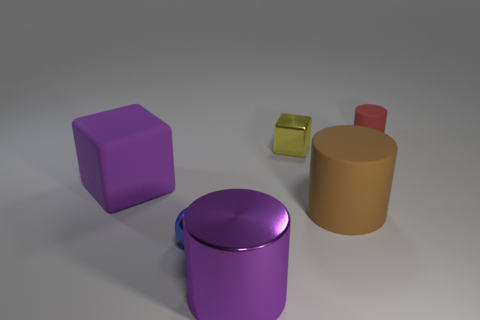Subtract all metallic cylinders. How many cylinders are left? 2 Subtract all brown cylinders. How many cylinders are left? 2 Add 2 large cubes. How many objects exist? 8 Subtract 1 cubes. How many cubes are left? 1 Subtract all blocks. How many objects are left? 4 Subtract all big green matte spheres. Subtract all matte cylinders. How many objects are left? 4 Add 6 big rubber cubes. How many big rubber cubes are left? 7 Add 5 small blue cubes. How many small blue cubes exist? 5 Subtract 0 purple spheres. How many objects are left? 6 Subtract all green spheres. Subtract all cyan cylinders. How many spheres are left? 1 